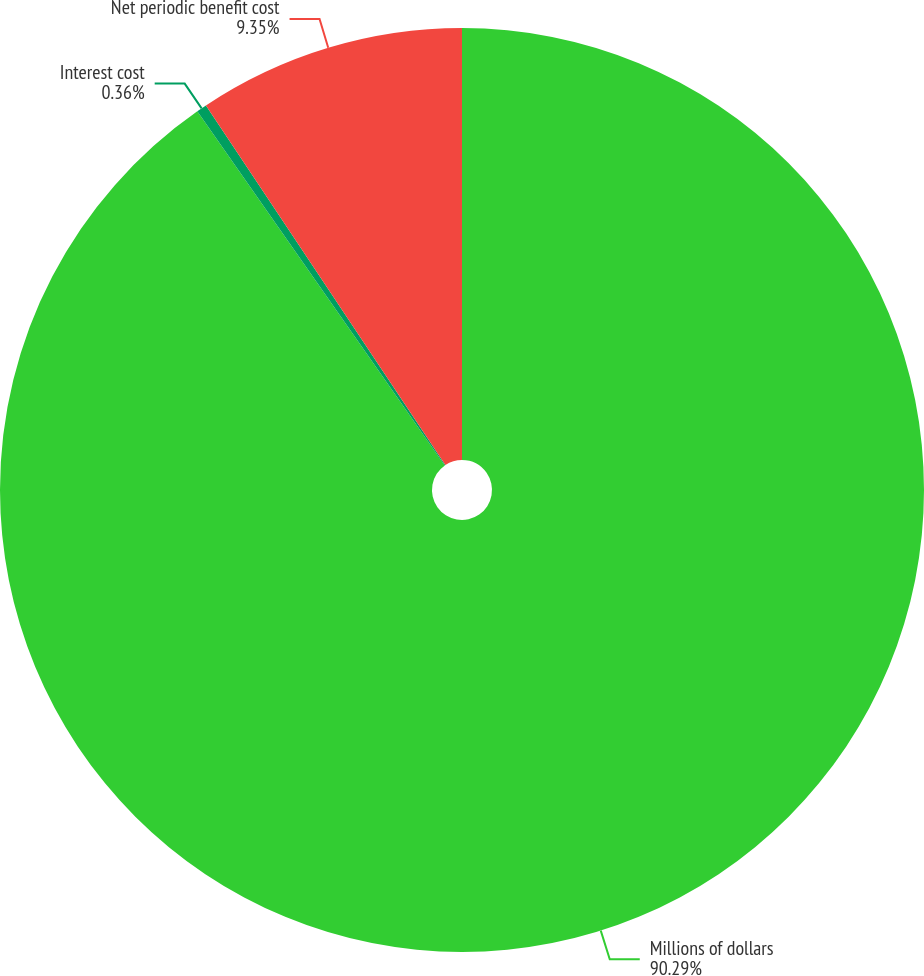Convert chart. <chart><loc_0><loc_0><loc_500><loc_500><pie_chart><fcel>Millions of dollars<fcel>Interest cost<fcel>Net periodic benefit cost<nl><fcel>90.29%<fcel>0.36%<fcel>9.35%<nl></chart> 